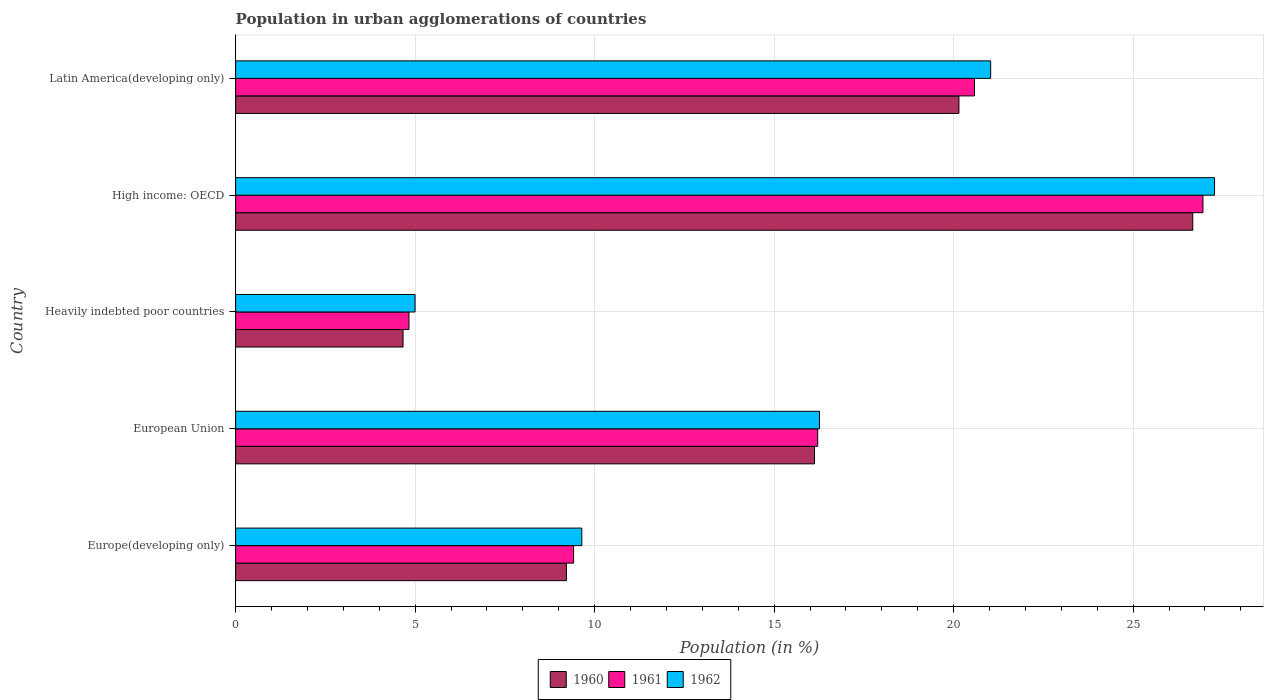How many different coloured bars are there?
Ensure brevity in your answer.  3. What is the label of the 5th group of bars from the top?
Provide a short and direct response. Europe(developing only). What is the percentage of population in urban agglomerations in 1961 in European Union?
Your answer should be compact. 16.21. Across all countries, what is the maximum percentage of population in urban agglomerations in 1962?
Offer a very short reply. 27.27. Across all countries, what is the minimum percentage of population in urban agglomerations in 1961?
Give a very brief answer. 4.83. In which country was the percentage of population in urban agglomerations in 1962 maximum?
Your response must be concise. High income: OECD. In which country was the percentage of population in urban agglomerations in 1961 minimum?
Your answer should be compact. Heavily indebted poor countries. What is the total percentage of population in urban agglomerations in 1962 in the graph?
Provide a succinct answer. 79.2. What is the difference between the percentage of population in urban agglomerations in 1960 in Heavily indebted poor countries and that in High income: OECD?
Your answer should be compact. -22. What is the difference between the percentage of population in urban agglomerations in 1962 in Europe(developing only) and the percentage of population in urban agglomerations in 1961 in European Union?
Provide a succinct answer. -6.57. What is the average percentage of population in urban agglomerations in 1962 per country?
Your answer should be compact. 15.84. What is the difference between the percentage of population in urban agglomerations in 1962 and percentage of population in urban agglomerations in 1960 in Heavily indebted poor countries?
Make the answer very short. 0.33. What is the ratio of the percentage of population in urban agglomerations in 1960 in Heavily indebted poor countries to that in Latin America(developing only)?
Offer a terse response. 0.23. Is the percentage of population in urban agglomerations in 1961 in Europe(developing only) less than that in Latin America(developing only)?
Give a very brief answer. Yes. What is the difference between the highest and the second highest percentage of population in urban agglomerations in 1962?
Offer a terse response. 6.24. What is the difference between the highest and the lowest percentage of population in urban agglomerations in 1960?
Ensure brevity in your answer.  22. How many bars are there?
Keep it short and to the point. 15. Are all the bars in the graph horizontal?
Offer a terse response. Yes. What is the difference between two consecutive major ticks on the X-axis?
Offer a terse response. 5. Are the values on the major ticks of X-axis written in scientific E-notation?
Give a very brief answer. No. Where does the legend appear in the graph?
Provide a succinct answer. Bottom center. How many legend labels are there?
Offer a very short reply. 3. What is the title of the graph?
Your response must be concise. Population in urban agglomerations of countries. What is the Population (in %) of 1960 in Europe(developing only)?
Your response must be concise. 9.21. What is the Population (in %) in 1961 in Europe(developing only)?
Provide a short and direct response. 9.41. What is the Population (in %) of 1962 in Europe(developing only)?
Give a very brief answer. 9.64. What is the Population (in %) of 1960 in European Union?
Give a very brief answer. 16.12. What is the Population (in %) of 1961 in European Union?
Give a very brief answer. 16.21. What is the Population (in %) in 1962 in European Union?
Offer a very short reply. 16.26. What is the Population (in %) of 1960 in Heavily indebted poor countries?
Give a very brief answer. 4.66. What is the Population (in %) in 1961 in Heavily indebted poor countries?
Ensure brevity in your answer.  4.83. What is the Population (in %) in 1962 in Heavily indebted poor countries?
Give a very brief answer. 5. What is the Population (in %) of 1960 in High income: OECD?
Your answer should be very brief. 26.66. What is the Population (in %) in 1961 in High income: OECD?
Your answer should be compact. 26.94. What is the Population (in %) of 1962 in High income: OECD?
Make the answer very short. 27.27. What is the Population (in %) of 1960 in Latin America(developing only)?
Provide a short and direct response. 20.15. What is the Population (in %) in 1961 in Latin America(developing only)?
Offer a terse response. 20.58. What is the Population (in %) in 1962 in Latin America(developing only)?
Your answer should be compact. 21.03. Across all countries, what is the maximum Population (in %) in 1960?
Your answer should be very brief. 26.66. Across all countries, what is the maximum Population (in %) of 1961?
Provide a short and direct response. 26.94. Across all countries, what is the maximum Population (in %) in 1962?
Keep it short and to the point. 27.27. Across all countries, what is the minimum Population (in %) of 1960?
Keep it short and to the point. 4.66. Across all countries, what is the minimum Population (in %) in 1961?
Keep it short and to the point. 4.83. Across all countries, what is the minimum Population (in %) of 1962?
Your answer should be very brief. 5. What is the total Population (in %) in 1960 in the graph?
Your answer should be compact. 76.81. What is the total Population (in %) of 1961 in the graph?
Keep it short and to the point. 77.98. What is the total Population (in %) of 1962 in the graph?
Offer a very short reply. 79.2. What is the difference between the Population (in %) in 1960 in Europe(developing only) and that in European Union?
Your response must be concise. -6.91. What is the difference between the Population (in %) in 1961 in Europe(developing only) and that in European Union?
Give a very brief answer. -6.8. What is the difference between the Population (in %) in 1962 in Europe(developing only) and that in European Union?
Give a very brief answer. -6.62. What is the difference between the Population (in %) in 1960 in Europe(developing only) and that in Heavily indebted poor countries?
Your answer should be very brief. 4.55. What is the difference between the Population (in %) in 1961 in Europe(developing only) and that in Heavily indebted poor countries?
Offer a terse response. 4.59. What is the difference between the Population (in %) of 1962 in Europe(developing only) and that in Heavily indebted poor countries?
Give a very brief answer. 4.65. What is the difference between the Population (in %) in 1960 in Europe(developing only) and that in High income: OECD?
Your response must be concise. -17.45. What is the difference between the Population (in %) of 1961 in Europe(developing only) and that in High income: OECD?
Make the answer very short. -17.53. What is the difference between the Population (in %) of 1962 in Europe(developing only) and that in High income: OECD?
Offer a terse response. -17.62. What is the difference between the Population (in %) in 1960 in Europe(developing only) and that in Latin America(developing only)?
Offer a very short reply. -10.93. What is the difference between the Population (in %) in 1961 in Europe(developing only) and that in Latin America(developing only)?
Your answer should be very brief. -11.17. What is the difference between the Population (in %) of 1962 in Europe(developing only) and that in Latin America(developing only)?
Your answer should be very brief. -11.39. What is the difference between the Population (in %) of 1960 in European Union and that in Heavily indebted poor countries?
Offer a terse response. 11.46. What is the difference between the Population (in %) in 1961 in European Union and that in Heavily indebted poor countries?
Your answer should be very brief. 11.39. What is the difference between the Population (in %) of 1962 in European Union and that in Heavily indebted poor countries?
Offer a very short reply. 11.26. What is the difference between the Population (in %) of 1960 in European Union and that in High income: OECD?
Your response must be concise. -10.54. What is the difference between the Population (in %) in 1961 in European Union and that in High income: OECD?
Provide a short and direct response. -10.73. What is the difference between the Population (in %) of 1962 in European Union and that in High income: OECD?
Offer a terse response. -11. What is the difference between the Population (in %) in 1960 in European Union and that in Latin America(developing only)?
Offer a very short reply. -4.02. What is the difference between the Population (in %) in 1961 in European Union and that in Latin America(developing only)?
Provide a short and direct response. -4.37. What is the difference between the Population (in %) of 1962 in European Union and that in Latin America(developing only)?
Keep it short and to the point. -4.77. What is the difference between the Population (in %) in 1960 in Heavily indebted poor countries and that in High income: OECD?
Offer a terse response. -22. What is the difference between the Population (in %) in 1961 in Heavily indebted poor countries and that in High income: OECD?
Give a very brief answer. -22.12. What is the difference between the Population (in %) of 1962 in Heavily indebted poor countries and that in High income: OECD?
Your response must be concise. -22.27. What is the difference between the Population (in %) of 1960 in Heavily indebted poor countries and that in Latin America(developing only)?
Make the answer very short. -15.48. What is the difference between the Population (in %) in 1961 in Heavily indebted poor countries and that in Latin America(developing only)?
Ensure brevity in your answer.  -15.75. What is the difference between the Population (in %) of 1962 in Heavily indebted poor countries and that in Latin America(developing only)?
Offer a terse response. -16.03. What is the difference between the Population (in %) of 1960 in High income: OECD and that in Latin America(developing only)?
Give a very brief answer. 6.51. What is the difference between the Population (in %) in 1961 in High income: OECD and that in Latin America(developing only)?
Your response must be concise. 6.36. What is the difference between the Population (in %) in 1962 in High income: OECD and that in Latin America(developing only)?
Ensure brevity in your answer.  6.24. What is the difference between the Population (in %) of 1960 in Europe(developing only) and the Population (in %) of 1961 in European Union?
Offer a very short reply. -7. What is the difference between the Population (in %) of 1960 in Europe(developing only) and the Population (in %) of 1962 in European Union?
Make the answer very short. -7.05. What is the difference between the Population (in %) of 1961 in Europe(developing only) and the Population (in %) of 1962 in European Union?
Offer a terse response. -6.85. What is the difference between the Population (in %) of 1960 in Europe(developing only) and the Population (in %) of 1961 in Heavily indebted poor countries?
Make the answer very short. 4.39. What is the difference between the Population (in %) of 1960 in Europe(developing only) and the Population (in %) of 1962 in Heavily indebted poor countries?
Keep it short and to the point. 4.22. What is the difference between the Population (in %) in 1961 in Europe(developing only) and the Population (in %) in 1962 in Heavily indebted poor countries?
Keep it short and to the point. 4.42. What is the difference between the Population (in %) in 1960 in Europe(developing only) and the Population (in %) in 1961 in High income: OECD?
Keep it short and to the point. -17.73. What is the difference between the Population (in %) of 1960 in Europe(developing only) and the Population (in %) of 1962 in High income: OECD?
Provide a succinct answer. -18.05. What is the difference between the Population (in %) of 1961 in Europe(developing only) and the Population (in %) of 1962 in High income: OECD?
Make the answer very short. -17.85. What is the difference between the Population (in %) of 1960 in Europe(developing only) and the Population (in %) of 1961 in Latin America(developing only)?
Give a very brief answer. -11.37. What is the difference between the Population (in %) in 1960 in Europe(developing only) and the Population (in %) in 1962 in Latin America(developing only)?
Offer a very short reply. -11.82. What is the difference between the Population (in %) in 1961 in Europe(developing only) and the Population (in %) in 1962 in Latin America(developing only)?
Provide a succinct answer. -11.62. What is the difference between the Population (in %) of 1960 in European Union and the Population (in %) of 1961 in Heavily indebted poor countries?
Your response must be concise. 11.3. What is the difference between the Population (in %) of 1960 in European Union and the Population (in %) of 1962 in Heavily indebted poor countries?
Keep it short and to the point. 11.13. What is the difference between the Population (in %) in 1961 in European Union and the Population (in %) in 1962 in Heavily indebted poor countries?
Give a very brief answer. 11.22. What is the difference between the Population (in %) of 1960 in European Union and the Population (in %) of 1961 in High income: OECD?
Offer a very short reply. -10.82. What is the difference between the Population (in %) of 1960 in European Union and the Population (in %) of 1962 in High income: OECD?
Keep it short and to the point. -11.14. What is the difference between the Population (in %) in 1961 in European Union and the Population (in %) in 1962 in High income: OECD?
Provide a succinct answer. -11.05. What is the difference between the Population (in %) of 1960 in European Union and the Population (in %) of 1961 in Latin America(developing only)?
Your answer should be compact. -4.46. What is the difference between the Population (in %) in 1960 in European Union and the Population (in %) in 1962 in Latin America(developing only)?
Provide a succinct answer. -4.91. What is the difference between the Population (in %) of 1961 in European Union and the Population (in %) of 1962 in Latin America(developing only)?
Give a very brief answer. -4.82. What is the difference between the Population (in %) in 1960 in Heavily indebted poor countries and the Population (in %) in 1961 in High income: OECD?
Your response must be concise. -22.28. What is the difference between the Population (in %) in 1960 in Heavily indebted poor countries and the Population (in %) in 1962 in High income: OECD?
Keep it short and to the point. -22.6. What is the difference between the Population (in %) in 1961 in Heavily indebted poor countries and the Population (in %) in 1962 in High income: OECD?
Give a very brief answer. -22.44. What is the difference between the Population (in %) in 1960 in Heavily indebted poor countries and the Population (in %) in 1961 in Latin America(developing only)?
Keep it short and to the point. -15.92. What is the difference between the Population (in %) in 1960 in Heavily indebted poor countries and the Population (in %) in 1962 in Latin America(developing only)?
Your answer should be compact. -16.37. What is the difference between the Population (in %) in 1961 in Heavily indebted poor countries and the Population (in %) in 1962 in Latin America(developing only)?
Your response must be concise. -16.2. What is the difference between the Population (in %) of 1960 in High income: OECD and the Population (in %) of 1961 in Latin America(developing only)?
Your answer should be very brief. 6.08. What is the difference between the Population (in %) in 1960 in High income: OECD and the Population (in %) in 1962 in Latin America(developing only)?
Offer a very short reply. 5.63. What is the difference between the Population (in %) of 1961 in High income: OECD and the Population (in %) of 1962 in Latin America(developing only)?
Provide a short and direct response. 5.91. What is the average Population (in %) in 1960 per country?
Offer a very short reply. 15.36. What is the average Population (in %) in 1961 per country?
Offer a terse response. 15.6. What is the average Population (in %) of 1962 per country?
Keep it short and to the point. 15.84. What is the difference between the Population (in %) of 1960 and Population (in %) of 1961 in Europe(developing only)?
Make the answer very short. -0.2. What is the difference between the Population (in %) of 1960 and Population (in %) of 1962 in Europe(developing only)?
Ensure brevity in your answer.  -0.43. What is the difference between the Population (in %) of 1961 and Population (in %) of 1962 in Europe(developing only)?
Give a very brief answer. -0.23. What is the difference between the Population (in %) in 1960 and Population (in %) in 1961 in European Union?
Provide a succinct answer. -0.09. What is the difference between the Population (in %) in 1960 and Population (in %) in 1962 in European Union?
Your response must be concise. -0.14. What is the difference between the Population (in %) of 1961 and Population (in %) of 1962 in European Union?
Your response must be concise. -0.05. What is the difference between the Population (in %) of 1960 and Population (in %) of 1961 in Heavily indebted poor countries?
Keep it short and to the point. -0.16. What is the difference between the Population (in %) in 1960 and Population (in %) in 1962 in Heavily indebted poor countries?
Your response must be concise. -0.33. What is the difference between the Population (in %) in 1961 and Population (in %) in 1962 in Heavily indebted poor countries?
Offer a terse response. -0.17. What is the difference between the Population (in %) of 1960 and Population (in %) of 1961 in High income: OECD?
Offer a very short reply. -0.28. What is the difference between the Population (in %) of 1960 and Population (in %) of 1962 in High income: OECD?
Your response must be concise. -0.61. What is the difference between the Population (in %) of 1961 and Population (in %) of 1962 in High income: OECD?
Your answer should be very brief. -0.32. What is the difference between the Population (in %) of 1960 and Population (in %) of 1961 in Latin America(developing only)?
Your answer should be very brief. -0.43. What is the difference between the Population (in %) of 1960 and Population (in %) of 1962 in Latin America(developing only)?
Your answer should be very brief. -0.88. What is the difference between the Population (in %) of 1961 and Population (in %) of 1962 in Latin America(developing only)?
Provide a succinct answer. -0.45. What is the ratio of the Population (in %) of 1961 in Europe(developing only) to that in European Union?
Your answer should be very brief. 0.58. What is the ratio of the Population (in %) in 1962 in Europe(developing only) to that in European Union?
Your answer should be compact. 0.59. What is the ratio of the Population (in %) of 1960 in Europe(developing only) to that in Heavily indebted poor countries?
Give a very brief answer. 1.98. What is the ratio of the Population (in %) of 1961 in Europe(developing only) to that in Heavily indebted poor countries?
Provide a short and direct response. 1.95. What is the ratio of the Population (in %) of 1962 in Europe(developing only) to that in Heavily indebted poor countries?
Ensure brevity in your answer.  1.93. What is the ratio of the Population (in %) in 1960 in Europe(developing only) to that in High income: OECD?
Offer a very short reply. 0.35. What is the ratio of the Population (in %) of 1961 in Europe(developing only) to that in High income: OECD?
Provide a short and direct response. 0.35. What is the ratio of the Population (in %) of 1962 in Europe(developing only) to that in High income: OECD?
Your answer should be very brief. 0.35. What is the ratio of the Population (in %) of 1960 in Europe(developing only) to that in Latin America(developing only)?
Your response must be concise. 0.46. What is the ratio of the Population (in %) in 1961 in Europe(developing only) to that in Latin America(developing only)?
Offer a very short reply. 0.46. What is the ratio of the Population (in %) of 1962 in Europe(developing only) to that in Latin America(developing only)?
Your response must be concise. 0.46. What is the ratio of the Population (in %) of 1960 in European Union to that in Heavily indebted poor countries?
Ensure brevity in your answer.  3.46. What is the ratio of the Population (in %) in 1961 in European Union to that in Heavily indebted poor countries?
Give a very brief answer. 3.36. What is the ratio of the Population (in %) in 1962 in European Union to that in Heavily indebted poor countries?
Provide a succinct answer. 3.25. What is the ratio of the Population (in %) in 1960 in European Union to that in High income: OECD?
Your response must be concise. 0.6. What is the ratio of the Population (in %) in 1961 in European Union to that in High income: OECD?
Your answer should be very brief. 0.6. What is the ratio of the Population (in %) of 1962 in European Union to that in High income: OECD?
Your answer should be compact. 0.6. What is the ratio of the Population (in %) of 1960 in European Union to that in Latin America(developing only)?
Make the answer very short. 0.8. What is the ratio of the Population (in %) of 1961 in European Union to that in Latin America(developing only)?
Keep it short and to the point. 0.79. What is the ratio of the Population (in %) in 1962 in European Union to that in Latin America(developing only)?
Provide a succinct answer. 0.77. What is the ratio of the Population (in %) of 1960 in Heavily indebted poor countries to that in High income: OECD?
Your answer should be compact. 0.17. What is the ratio of the Population (in %) in 1961 in Heavily indebted poor countries to that in High income: OECD?
Keep it short and to the point. 0.18. What is the ratio of the Population (in %) of 1962 in Heavily indebted poor countries to that in High income: OECD?
Your response must be concise. 0.18. What is the ratio of the Population (in %) in 1960 in Heavily indebted poor countries to that in Latin America(developing only)?
Your answer should be very brief. 0.23. What is the ratio of the Population (in %) of 1961 in Heavily indebted poor countries to that in Latin America(developing only)?
Ensure brevity in your answer.  0.23. What is the ratio of the Population (in %) of 1962 in Heavily indebted poor countries to that in Latin America(developing only)?
Your answer should be compact. 0.24. What is the ratio of the Population (in %) of 1960 in High income: OECD to that in Latin America(developing only)?
Make the answer very short. 1.32. What is the ratio of the Population (in %) in 1961 in High income: OECD to that in Latin America(developing only)?
Your answer should be very brief. 1.31. What is the ratio of the Population (in %) of 1962 in High income: OECD to that in Latin America(developing only)?
Your response must be concise. 1.3. What is the difference between the highest and the second highest Population (in %) of 1960?
Your response must be concise. 6.51. What is the difference between the highest and the second highest Population (in %) of 1961?
Offer a very short reply. 6.36. What is the difference between the highest and the second highest Population (in %) of 1962?
Offer a very short reply. 6.24. What is the difference between the highest and the lowest Population (in %) in 1960?
Your answer should be very brief. 22. What is the difference between the highest and the lowest Population (in %) in 1961?
Ensure brevity in your answer.  22.12. What is the difference between the highest and the lowest Population (in %) in 1962?
Make the answer very short. 22.27. 